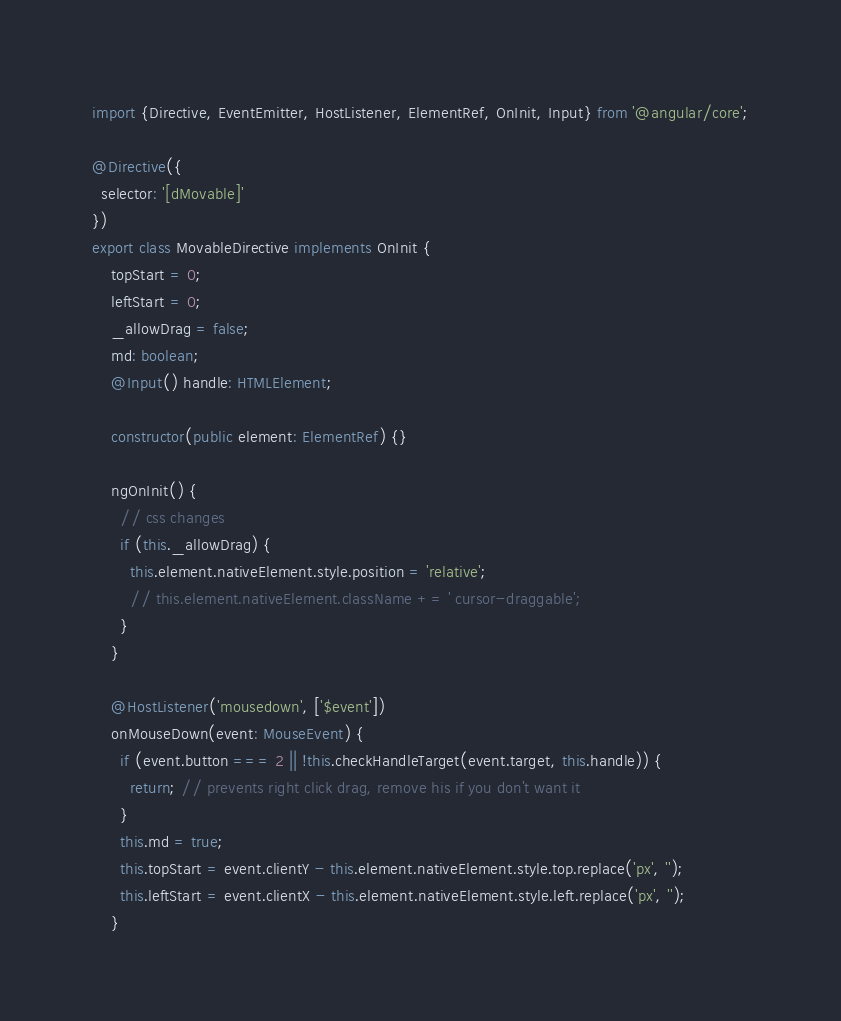<code> <loc_0><loc_0><loc_500><loc_500><_TypeScript_>import {Directive, EventEmitter, HostListener, ElementRef, OnInit, Input} from '@angular/core';

@Directive({
  selector: '[dMovable]'
})
export class MovableDirective implements OnInit {
    topStart = 0;
    leftStart = 0;
    _allowDrag = false;
    md: boolean;
    @Input() handle: HTMLElement;

    constructor(public element: ElementRef) {}

    ngOnInit() {
      // css changes
      if (this._allowDrag) {
        this.element.nativeElement.style.position = 'relative';
        // this.element.nativeElement.className += ' cursor-draggable';
      }
    }

    @HostListener('mousedown', ['$event'])
    onMouseDown(event: MouseEvent) {
      if (event.button === 2 || !this.checkHandleTarget(event.target, this.handle)) {
        return; // prevents right click drag, remove his if you don't want it
      }
      this.md = true;
      this.topStart = event.clientY - this.element.nativeElement.style.top.replace('px', '');
      this.leftStart = event.clientX - this.element.nativeElement.style.left.replace('px', '');
    }
</code> 